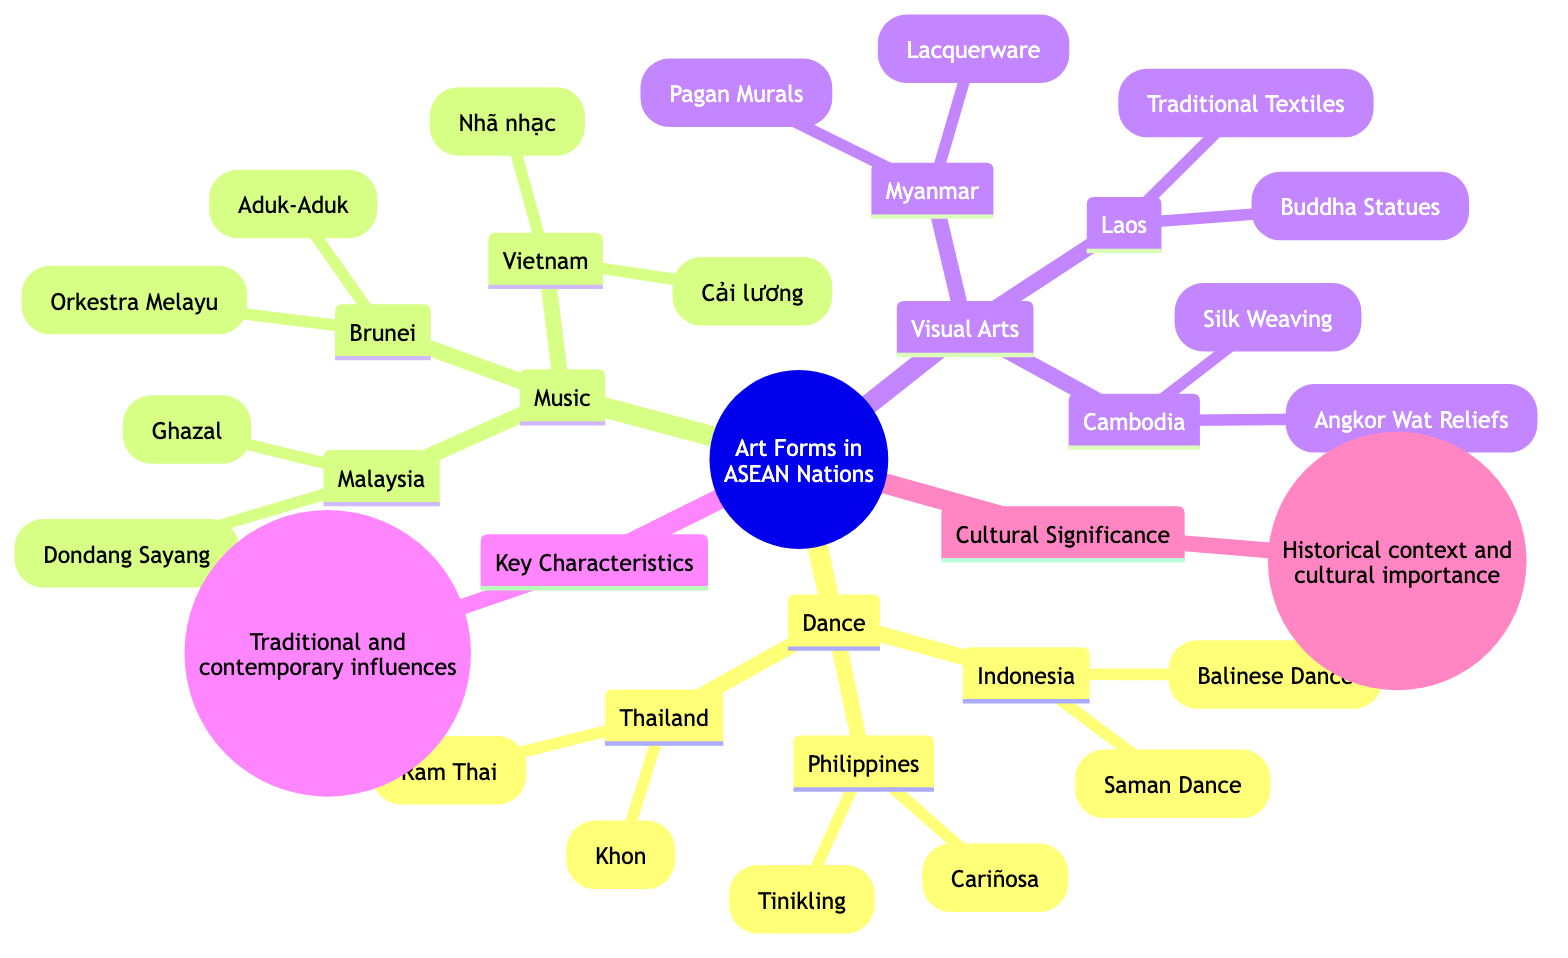What are the two dance forms from Indonesia? The diagram lists "Balinese Dance" and "Saman Dance" under the Indonesia node within the Dance section. Therefore, these are the two dance forms represented.
Answer: Balinese Dance, Saman Dance Which country features the Khon dance form? The diagram shows that the Khon is associated with Thailand as indicated in the Dance section.
Answer: Thailand How many visual arts are listed for Cambodia? Under the Visual Arts section for Cambodia, there are two entries: "Angkor Wat Reliefs" and "Silk Weaving." Therefore, there are two visual arts listed.
Answer: 2 What type of characteristics is highlighted in the diagram? The "Key Characteristics" node points to traditional and contemporary influences, which are emphasized in the diagram.
Answer: Traditional and contemporary influences Which ASEAN country showcases Buddha Statues in its visual arts? According to the Visual Arts section, Laos features "Buddha Statues" as one of its art forms. Hence, Laos is the answer.
Answer: Laos What are the two music forms from Malaysia? The diagram specifies "Ghazal" and "Dondang Sayang" under the Malaysia node in the Music section, which identifies these two forms.
Answer: Ghazal, Dondang Sayang How many dance forms are illustrated for the Philippines? The Philippines node under the Dance section lists two forms: "Tinikling" and "Cariñosa." Therefore, two forms are illustrated.
Answer: 2 Which country has the most art forms listed in the dance category based on the diagram? The diagram does not explicitly provide a count of art forms per country, but we see Indonesia, Thailand, and the Philippines each with two forms. Hence, no single country stands out as having more forms than others in the dance category.
Answer: None What is the cultural significance highlighted in the diagram? The "Cultural Significance" node emphasizes the historical context and cultural importance, which is directly taken from the diagram.
Answer: Historical context and cultural importance 